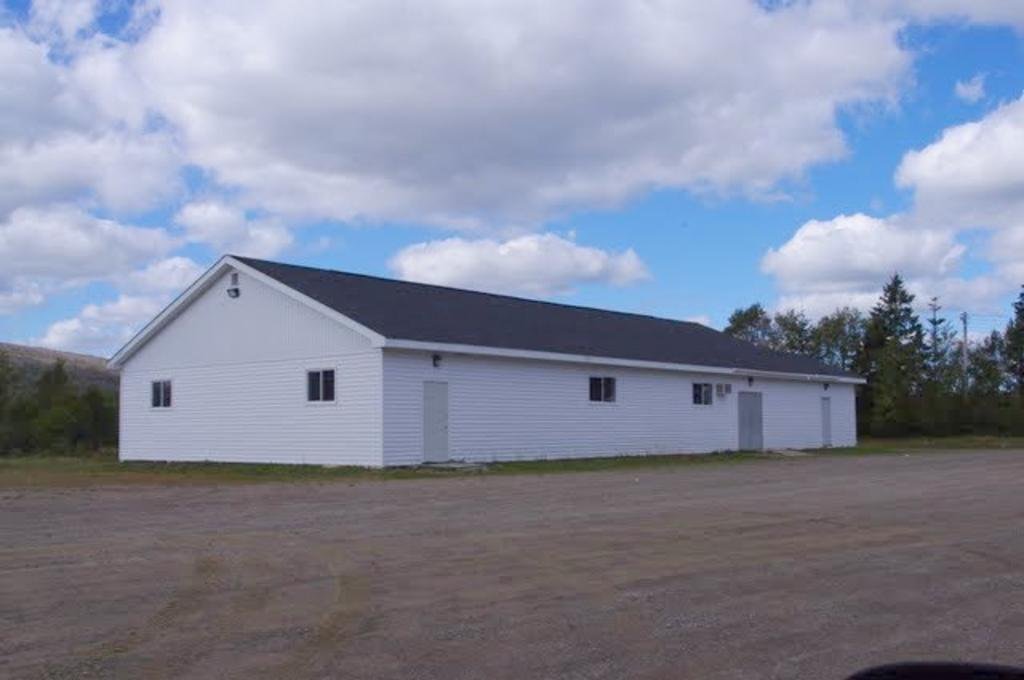What type of structure is in the image? There is a house in the image. What features can be seen on the house? The house has windows and doors. What else is visible in the image besides the house? There are trees and the sky in the image. What can be observed in the sky? Clouds are present in the sky. Where is the tray placed in the image? There is no tray present in the image. What type of laborer can be seen working in the image? There is no laborer present in the image. 